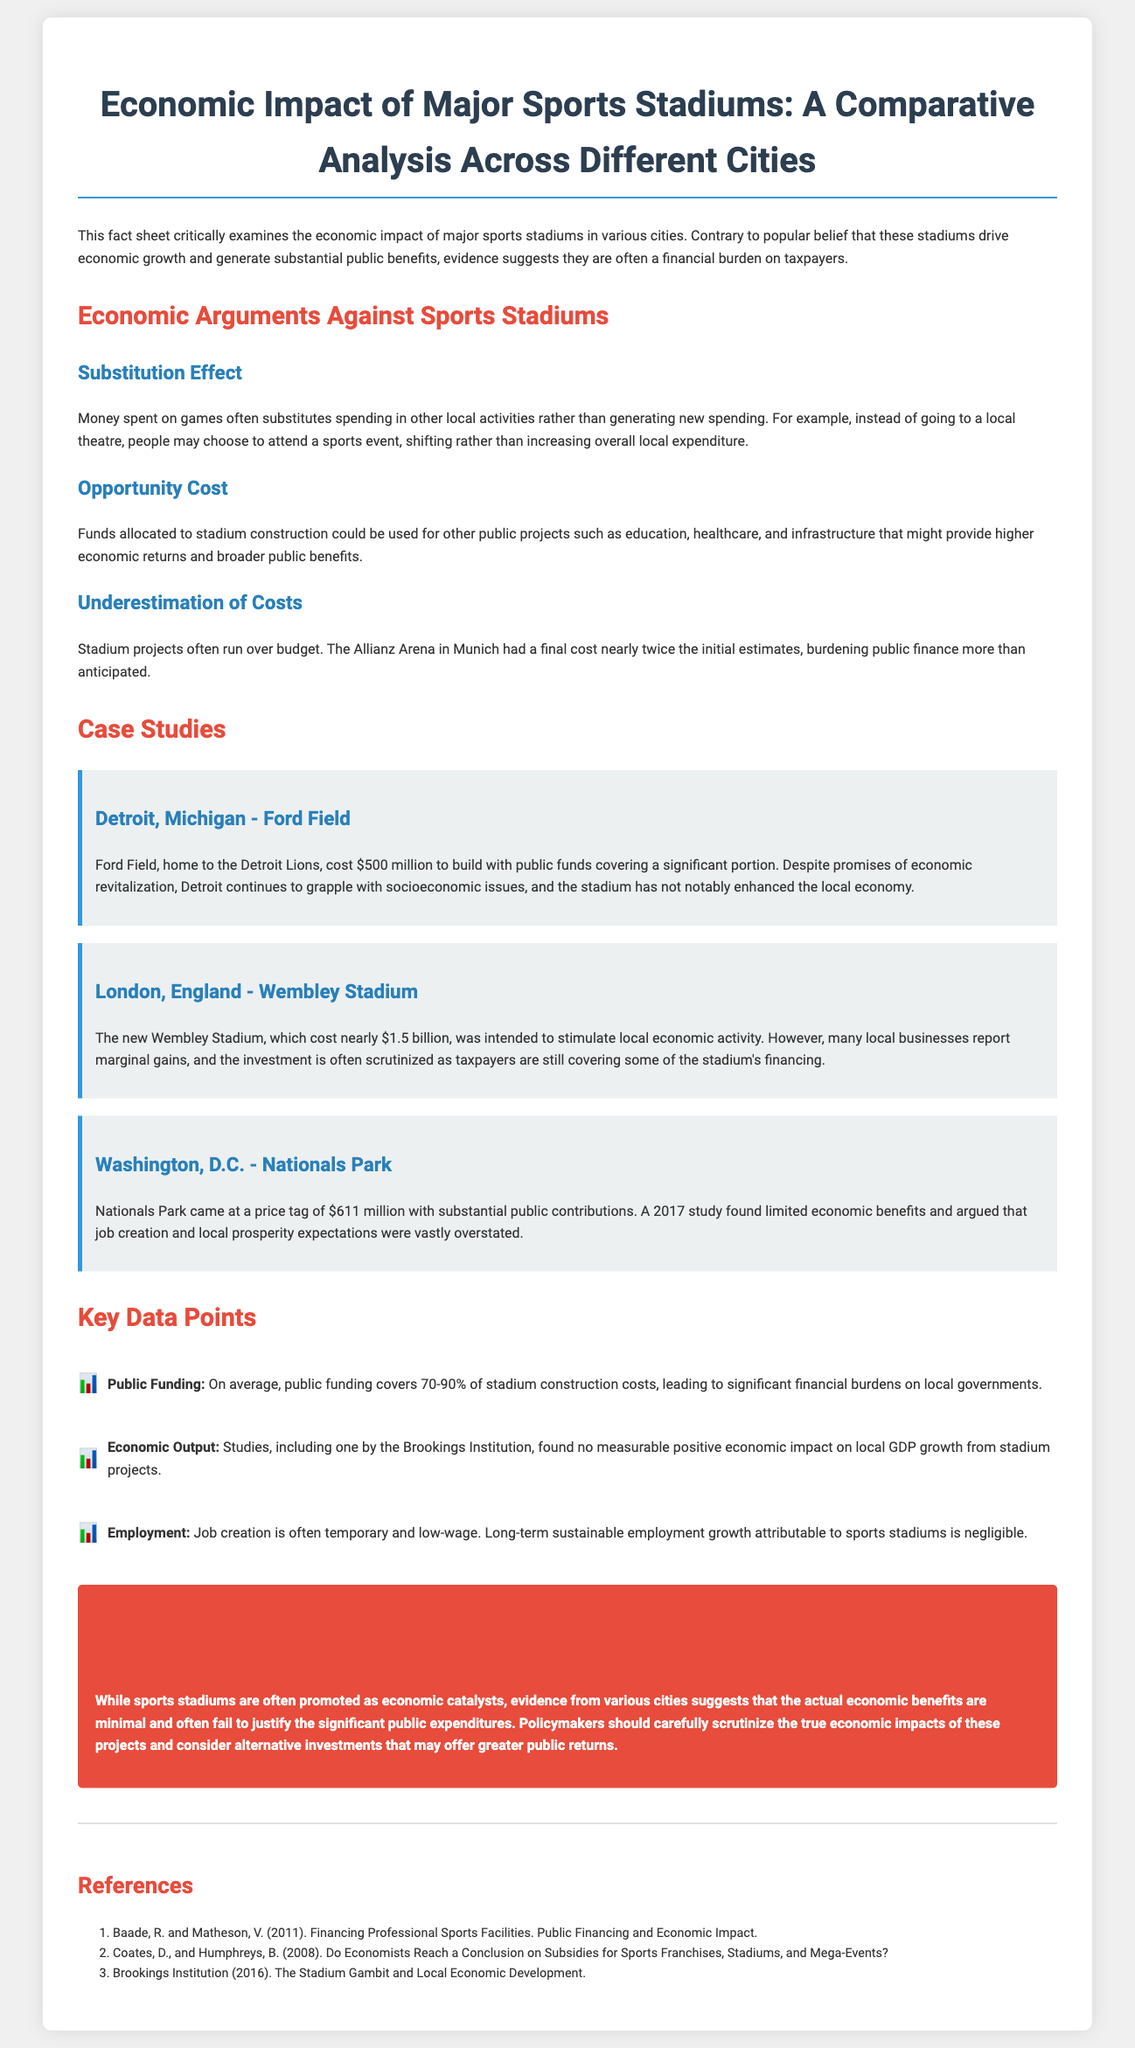What is the title of the document? The title of the document is prominently displayed at the top and introduces the main subject matter.
Answer: Economic Impact of Major Sports Stadiums: A Comparative Analysis Across Different Cities What is the estimated public funding percentage for stadium construction costs? The document specifies a range of public funding covering stadium costs, indicating the financial burden on local governments.
Answer: 70-90% Which case study is from Washington, D.C.? The case studies are listed, and each one is titled by the city where the stadium is located.
Answer: Nationals Park What was the cost of Ford Field? The document provides specific cost information for each case study.
Answer: $500 million What is one consequence of the substitution effect mentioned? The document explains the substitution effect and its impact on local spending activities.
Answer: Shift in spending What year was the study referenced for Nationals Park conducted? The document cites a specific year connected to the economic benefits of Nationals Park.
Answer: 2017 What is outlined as a reason for underestimated costs? The document discusses reasons behind project costs exceeding initial estimates.
Answer: Budget overruns According to the Brookings Institution, what impact did stadium projects have on local GDP growth? The document references findings from a study related to stadium projects and their economic impact.
Answer: No measurable positive impact What is the final conclusion of the document? The conclusion summarizes the overall findings and recommendations regarding sports stadium expenditures.
Answer: Minimal economic benefits 